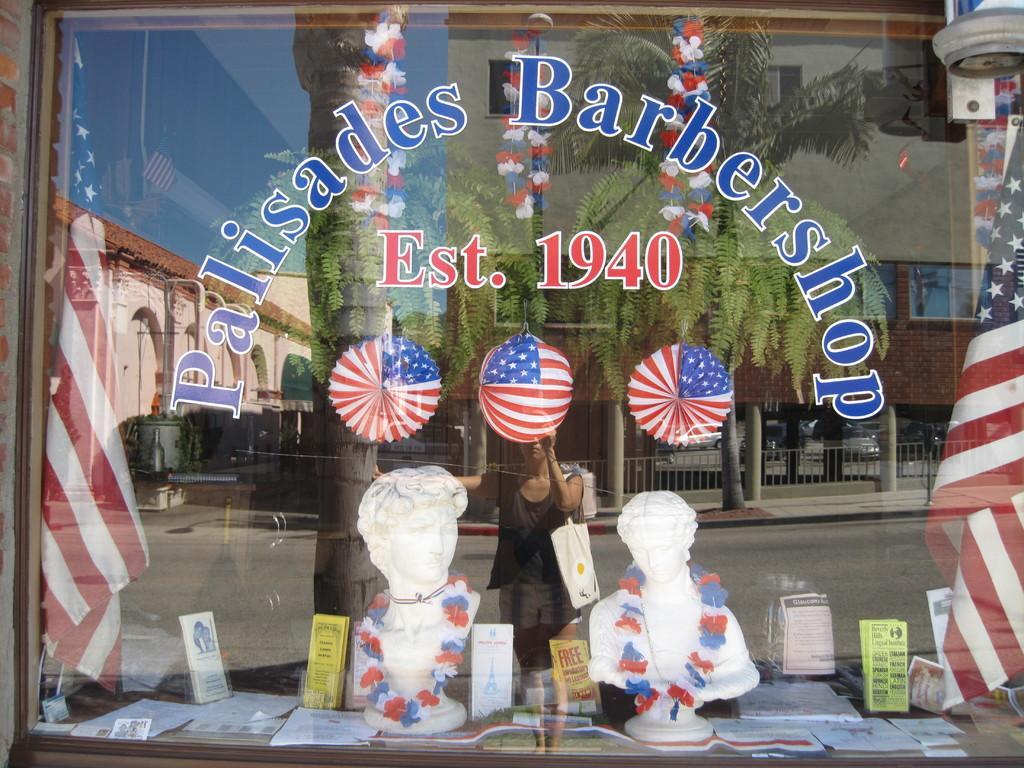Please provide a concise description of this image. In this image, we can see a glass object. Through the glass we can see sculptures, papers, flags and few objects. On the glass we can see a few reflections. We can see a woman wearing a bag, tree trunk, trees, building, houses, walls, glass objects, pillars, railings, few objects, road and the sky. 